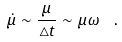Convert formula to latex. <formula><loc_0><loc_0><loc_500><loc_500>\dot { \mu } \sim \frac { \mu } { \triangle t } \sim \mu \omega \ \ .</formula> 